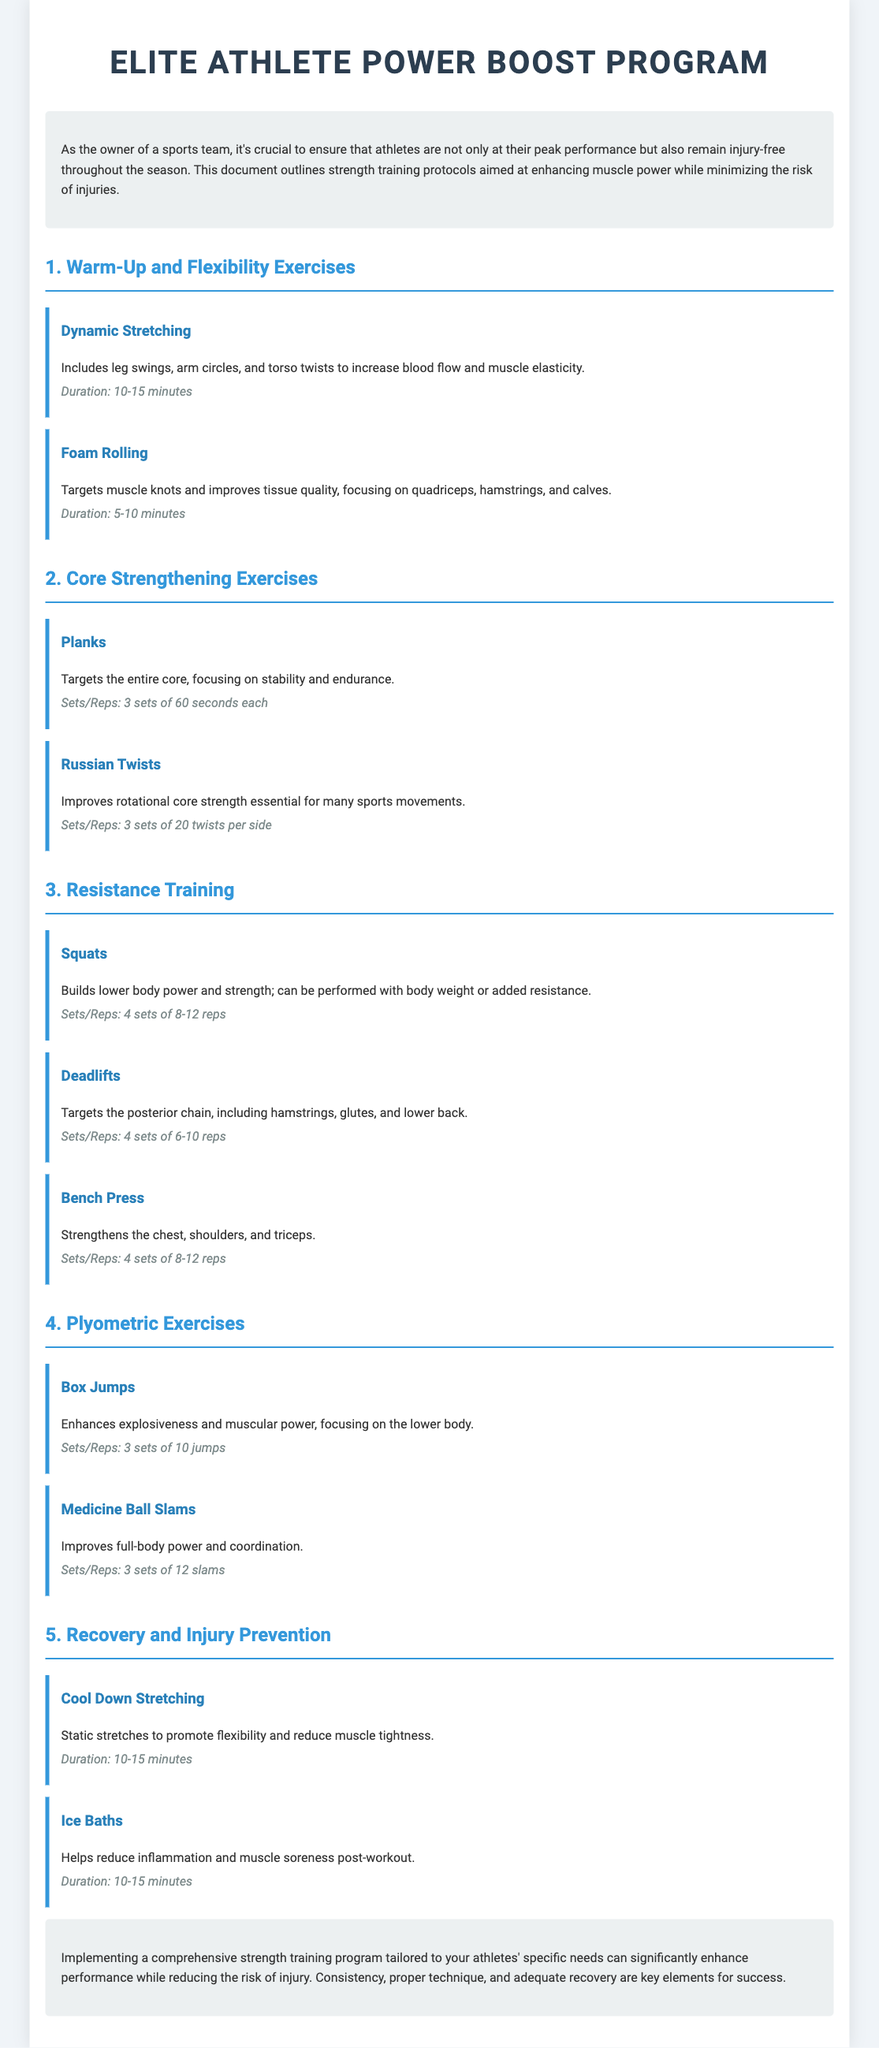What is the title of the program? The title is displayed prominently at the top of the document and is "Elite Athlete Power Boost Program."
Answer: Elite Athlete Power Boost Program How long should dynamic stretching last? The document specifies that dynamic stretching should last for 10-15 minutes.
Answer: 10-15 minutes What is the primary focus of Russian twists? The description of Russian twists highlights their improvement of rotational core strength essential for many sports movements.
Answer: Rotational core strength How many sets of squats are recommended? The document states that squats should be performed for 4 sets of 8-12 reps.
Answer: 4 sets What exercise is aimed at enhancing explosiveness? The document indicates that box jumps are designed to enhance explosiveness and muscular power.
Answer: Box Jumps What recovery method is suggested to reduce inflammation? The document mentions that ice baths help reduce inflammation and muscle soreness post-workout.
Answer: Ice Baths How many sets and reps are prescribed for planks? The recommended sets and repetitions for planks in the document are 3 sets of 60 seconds each.
Answer: 3 sets of 60 seconds What is the purpose of cool down stretching? The document states that cool down stretching promotes flexibility and reduces muscle tightness.
Answer: Promote flexibility How many medicine ball slams should be performed? The document recommends performing 3 sets of 12 slams for medicine ball slams.
Answer: 3 sets of 12 slams 